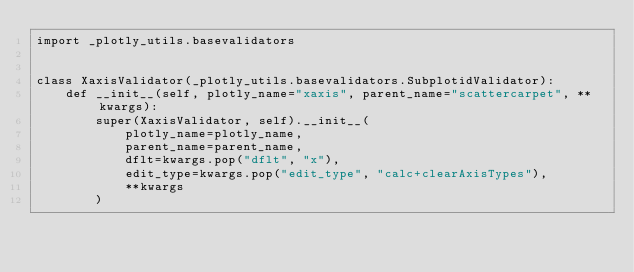<code> <loc_0><loc_0><loc_500><loc_500><_Python_>import _plotly_utils.basevalidators


class XaxisValidator(_plotly_utils.basevalidators.SubplotidValidator):
    def __init__(self, plotly_name="xaxis", parent_name="scattercarpet", **kwargs):
        super(XaxisValidator, self).__init__(
            plotly_name=plotly_name,
            parent_name=parent_name,
            dflt=kwargs.pop("dflt", "x"),
            edit_type=kwargs.pop("edit_type", "calc+clearAxisTypes"),
            **kwargs
        )
</code> 